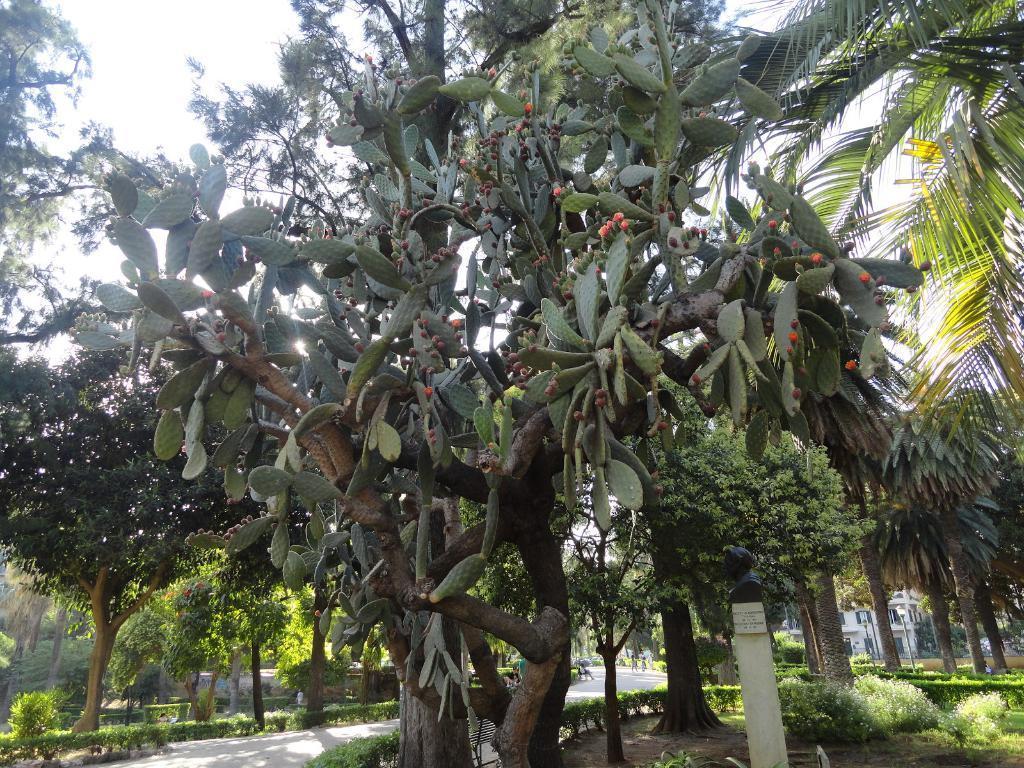Could you give a brief overview of what you see in this image? In this image we can see so many trees. Bottom of the image plants and pole are there. 